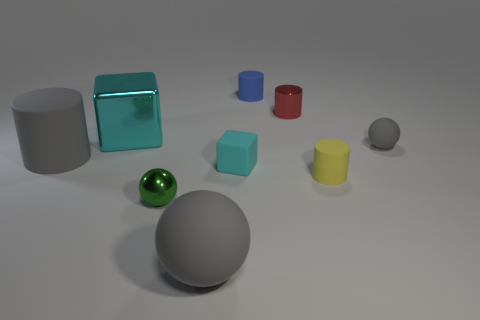Subtract 1 cylinders. How many cylinders are left? 3 Subtract all purple cubes. Subtract all cyan balls. How many cubes are left? 2 Subtract all blocks. How many objects are left? 7 Subtract 0 yellow blocks. How many objects are left? 9 Subtract all big objects. Subtract all small matte blocks. How many objects are left? 5 Add 1 big gray spheres. How many big gray spheres are left? 2 Add 8 large metal cubes. How many large metal cubes exist? 9 